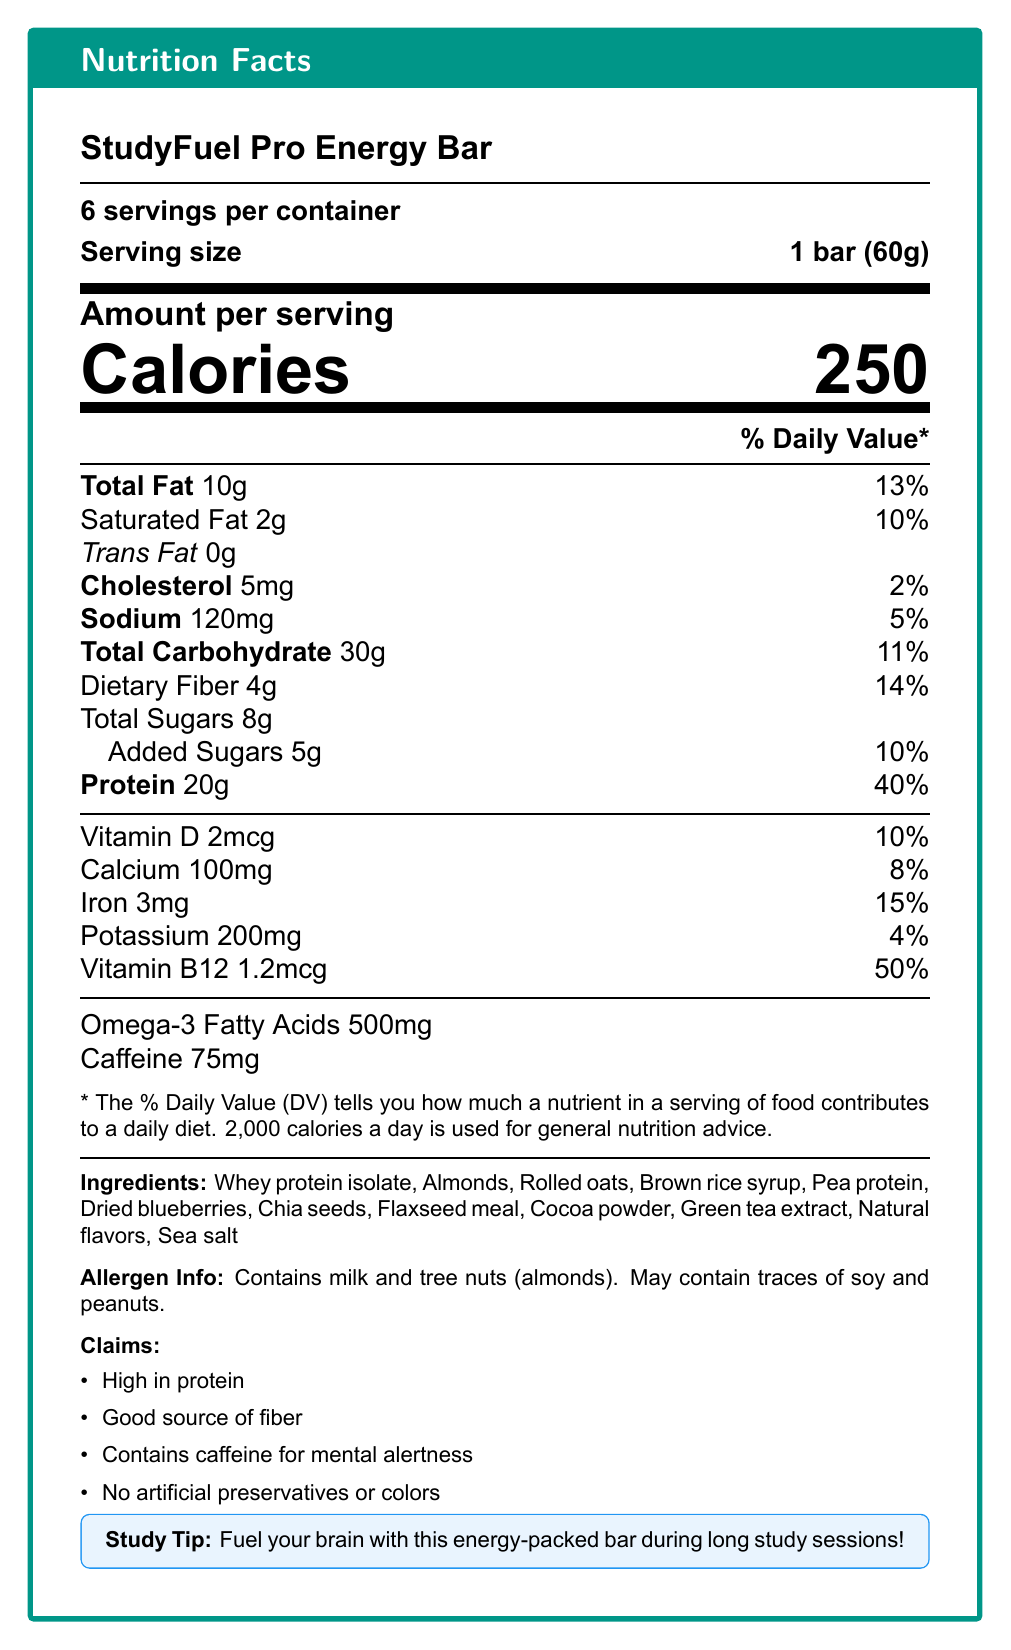What is the serving size of the StudyFuel Pro Energy Bar? The serving size of the StudyFuel Pro Energy Bar is explicitly stated as "1 bar (60g)" in the document.
Answer: 1 bar (60g) How many servings are there per container? The document states that there are 6 servings per container.
Answer: 6 servings per container What is the amount of calories per serving? The document mentions "Calories" as 250 per serving.
Answer: 250 How much total fat is in one serving and what percentage of the daily value does it correspond to? The total fat per serving is 10g, and it corresponds to 13% of the daily value.
Answer: 10g, 13% Does the StudyFuel Pro Energy Bar contain any trans fat? The document shows that the trans fat content is 0g, indicating that it does not contain any trans fat.
Answer: No What are the total carbohydrates in one serving, and what portion of the daily value does this represent? The total carbohydrates per serving are 30g, representing 11% of the daily value.
Answer: 30g, 11% How much protein is included in each serving of the StudyFuel Pro Energy Bar? A. 10g B. 20g C. 30g The document specifies that each serving contains 20g of protein.
Answer: B. 20g Which of the following nutrients is present in the greatest quantity per serving? A. Vitamin D B. Calcium C. Iron D. Potassium Iron is present in the greatest quantity per serving, with 15% of the daily value, compared to 10% for Vitamin D, 8% for Calcium, and 4% for Potassium.
Answer: C. Iron Does the StudyFuel Pro Energy Bar contain caffeine? The document lists "Caffeine 75mg," indicating that the bar contains caffeine.
Answer: Yes Are there any artificial preservatives or colors in the StudyFuel Pro Energy Bar? The document claims that the bar has no artificial preservatives or colors.
Answer: No Describe the main idea of the Nutrition Facts label for the StudyFuel Pro Energy Bar. The document is focused on giving comprehensive nutritional details of the StudyFuel Pro Energy Bar, emphasizing its high protein content, presence of beneficial ingredients like fiber and caffeine, and clean-label claims like no artificial preservatives or colors.
Answer: The Nutrition Facts label for the StudyFuel Pro Energy Bar provides detailed nutritional information per serving, including calories, macronutrient content (fats, carbohydrates, and proteins), and micronutrients (vitamins and minerals), along with specific ingredient details and allergen information. It highlights that the bar is high in protein, contains fiber, caffeine, and no artificial preservatives or colors, making it suitable for boosting mental alertness during study sessions. What is the main source of protein in the StudyFuel Pro Energy Bar? The main source of protein listed in the ingredients is "Whey protein isolate".
Answer: Whey protein isolate List two allergens that are present in the StudyFuel Pro Energy Bar. The allergen information specifies that the bar contains milk and tree nuts (almonds).
Answer: Milk and tree nuts (almonds) Can you determine the exact amount of caffeine needed per day from this document? The document provides the amount of caffeine in the energy bar (75mg), but does not provide information on the recommended daily intake of caffeine.
Answer: Cannot be determined What percentage of the daily value for Vitamin B12 does the StudyFuel Pro Energy Bar provide per serving? The bar provides 50% of the daily value for Vitamin B12 per serving, as shown in the document.
Answer: 50% 